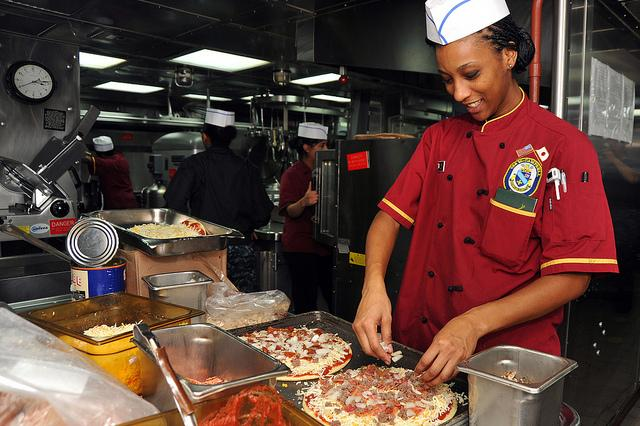What fungus is being added to this pie?

Choices:
A) lichens
B) squash
C) mushrooms
D) algae mushrooms 